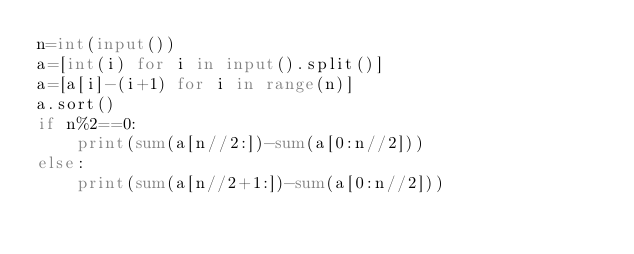Convert code to text. <code><loc_0><loc_0><loc_500><loc_500><_Python_>n=int(input())
a=[int(i) for i in input().split()]
a=[a[i]-(i+1) for i in range(n)]
a.sort()
if n%2==0:
    print(sum(a[n//2:])-sum(a[0:n//2]))
else:
    print(sum(a[n//2+1:])-sum(a[0:n//2]))
</code> 